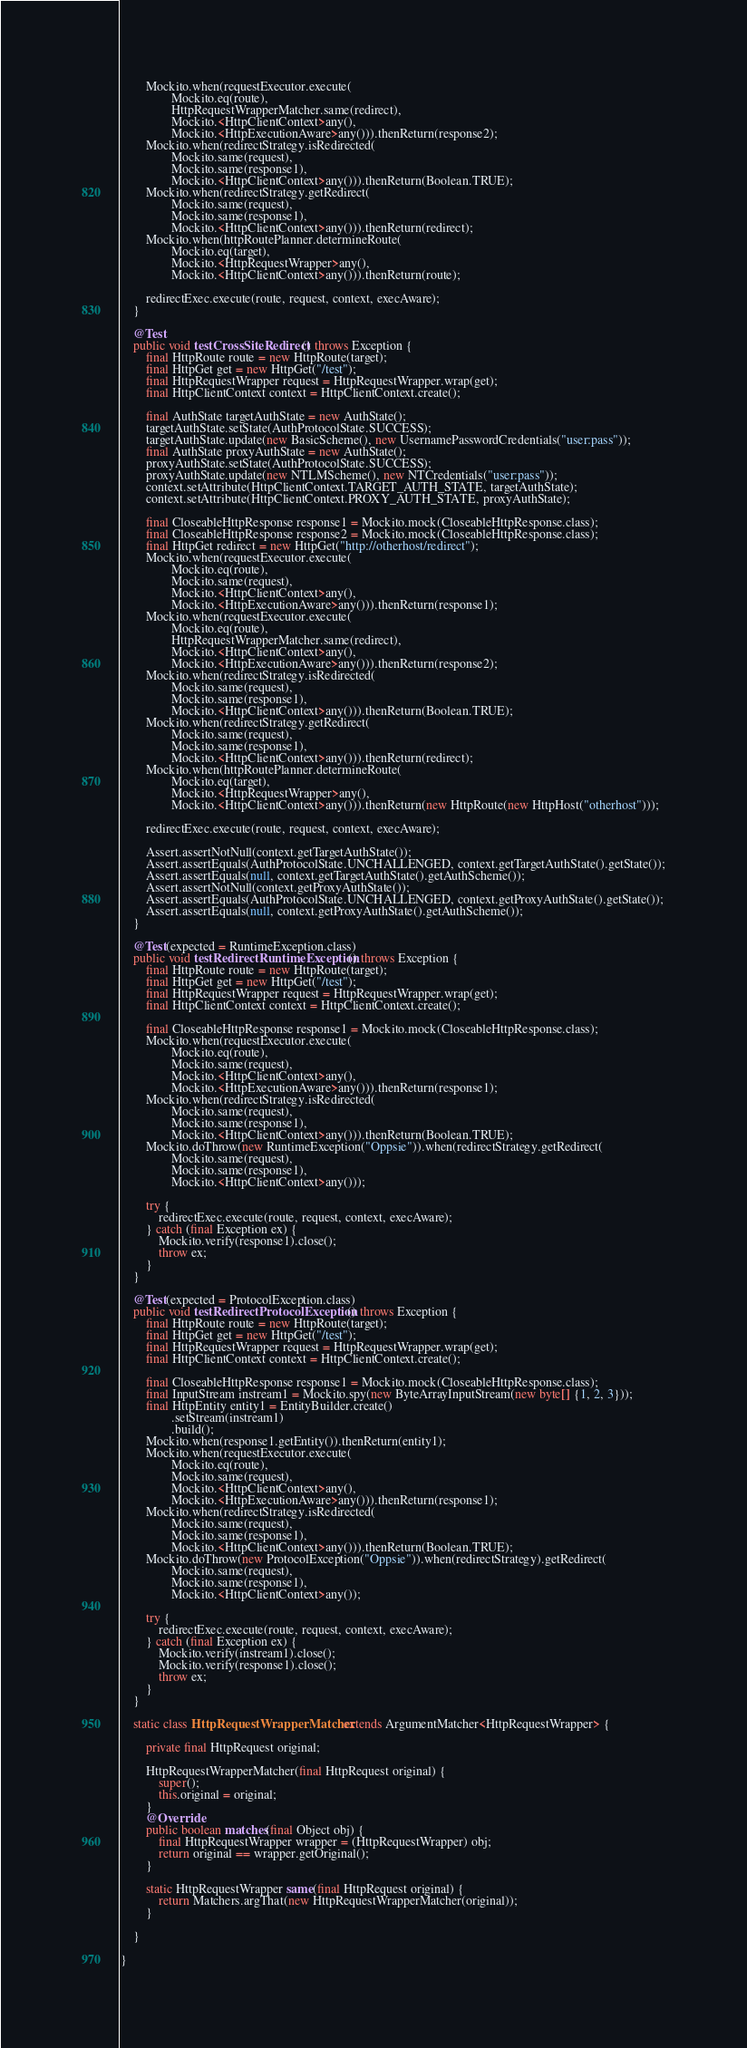<code> <loc_0><loc_0><loc_500><loc_500><_Java_>        Mockito.when(requestExecutor.execute(
                Mockito.eq(route),
                HttpRequestWrapperMatcher.same(redirect),
                Mockito.<HttpClientContext>any(),
                Mockito.<HttpExecutionAware>any())).thenReturn(response2);
        Mockito.when(redirectStrategy.isRedirected(
                Mockito.same(request),
                Mockito.same(response1),
                Mockito.<HttpClientContext>any())).thenReturn(Boolean.TRUE);
        Mockito.when(redirectStrategy.getRedirect(
                Mockito.same(request),
                Mockito.same(response1),
                Mockito.<HttpClientContext>any())).thenReturn(redirect);
        Mockito.when(httpRoutePlanner.determineRoute(
                Mockito.eq(target),
                Mockito.<HttpRequestWrapper>any(),
                Mockito.<HttpClientContext>any())).thenReturn(route);

        redirectExec.execute(route, request, context, execAware);
    }

    @Test
    public void testCrossSiteRedirect() throws Exception {
        final HttpRoute route = new HttpRoute(target);
        final HttpGet get = new HttpGet("/test");
        final HttpRequestWrapper request = HttpRequestWrapper.wrap(get);
        final HttpClientContext context = HttpClientContext.create();

        final AuthState targetAuthState = new AuthState();
        targetAuthState.setState(AuthProtocolState.SUCCESS);
        targetAuthState.update(new BasicScheme(), new UsernamePasswordCredentials("user:pass"));
        final AuthState proxyAuthState = new AuthState();
        proxyAuthState.setState(AuthProtocolState.SUCCESS);
        proxyAuthState.update(new NTLMScheme(), new NTCredentials("user:pass"));
        context.setAttribute(HttpClientContext.TARGET_AUTH_STATE, targetAuthState);
        context.setAttribute(HttpClientContext.PROXY_AUTH_STATE, proxyAuthState);

        final CloseableHttpResponse response1 = Mockito.mock(CloseableHttpResponse.class);
        final CloseableHttpResponse response2 = Mockito.mock(CloseableHttpResponse.class);
        final HttpGet redirect = new HttpGet("http://otherhost/redirect");
        Mockito.when(requestExecutor.execute(
                Mockito.eq(route),
                Mockito.same(request),
                Mockito.<HttpClientContext>any(),
                Mockito.<HttpExecutionAware>any())).thenReturn(response1);
        Mockito.when(requestExecutor.execute(
                Mockito.eq(route),
                HttpRequestWrapperMatcher.same(redirect),
                Mockito.<HttpClientContext>any(),
                Mockito.<HttpExecutionAware>any())).thenReturn(response2);
        Mockito.when(redirectStrategy.isRedirected(
                Mockito.same(request),
                Mockito.same(response1),
                Mockito.<HttpClientContext>any())).thenReturn(Boolean.TRUE);
        Mockito.when(redirectStrategy.getRedirect(
                Mockito.same(request),
                Mockito.same(response1),
                Mockito.<HttpClientContext>any())).thenReturn(redirect);
        Mockito.when(httpRoutePlanner.determineRoute(
                Mockito.eq(target),
                Mockito.<HttpRequestWrapper>any(),
                Mockito.<HttpClientContext>any())).thenReturn(new HttpRoute(new HttpHost("otherhost")));

        redirectExec.execute(route, request, context, execAware);

        Assert.assertNotNull(context.getTargetAuthState());
        Assert.assertEquals(AuthProtocolState.UNCHALLENGED, context.getTargetAuthState().getState());
        Assert.assertEquals(null, context.getTargetAuthState().getAuthScheme());
        Assert.assertNotNull(context.getProxyAuthState());
        Assert.assertEquals(AuthProtocolState.UNCHALLENGED, context.getProxyAuthState().getState());
        Assert.assertEquals(null, context.getProxyAuthState().getAuthScheme());
    }

    @Test(expected = RuntimeException.class)
    public void testRedirectRuntimeException() throws Exception {
        final HttpRoute route = new HttpRoute(target);
        final HttpGet get = new HttpGet("/test");
        final HttpRequestWrapper request = HttpRequestWrapper.wrap(get);
        final HttpClientContext context = HttpClientContext.create();

        final CloseableHttpResponse response1 = Mockito.mock(CloseableHttpResponse.class);
        Mockito.when(requestExecutor.execute(
                Mockito.eq(route),
                Mockito.same(request),
                Mockito.<HttpClientContext>any(),
                Mockito.<HttpExecutionAware>any())).thenReturn(response1);
        Mockito.when(redirectStrategy.isRedirected(
                Mockito.same(request),
                Mockito.same(response1),
                Mockito.<HttpClientContext>any())).thenReturn(Boolean.TRUE);
        Mockito.doThrow(new RuntimeException("Oppsie")).when(redirectStrategy.getRedirect(
                Mockito.same(request),
                Mockito.same(response1),
                Mockito.<HttpClientContext>any()));

        try {
            redirectExec.execute(route, request, context, execAware);
        } catch (final Exception ex) {
            Mockito.verify(response1).close();
            throw ex;
        }
    }

    @Test(expected = ProtocolException.class)
    public void testRedirectProtocolException() throws Exception {
        final HttpRoute route = new HttpRoute(target);
        final HttpGet get = new HttpGet("/test");
        final HttpRequestWrapper request = HttpRequestWrapper.wrap(get);
        final HttpClientContext context = HttpClientContext.create();

        final CloseableHttpResponse response1 = Mockito.mock(CloseableHttpResponse.class);
        final InputStream instream1 = Mockito.spy(new ByteArrayInputStream(new byte[] {1, 2, 3}));
        final HttpEntity entity1 = EntityBuilder.create()
                .setStream(instream1)
                .build();
        Mockito.when(response1.getEntity()).thenReturn(entity1);
        Mockito.when(requestExecutor.execute(
                Mockito.eq(route),
                Mockito.same(request),
                Mockito.<HttpClientContext>any(),
                Mockito.<HttpExecutionAware>any())).thenReturn(response1);
        Mockito.when(redirectStrategy.isRedirected(
                Mockito.same(request),
                Mockito.same(response1),
                Mockito.<HttpClientContext>any())).thenReturn(Boolean.TRUE);
        Mockito.doThrow(new ProtocolException("Oppsie")).when(redirectStrategy).getRedirect(
                Mockito.same(request),
                Mockito.same(response1),
                Mockito.<HttpClientContext>any());

        try {
            redirectExec.execute(route, request, context, execAware);
        } catch (final Exception ex) {
            Mockito.verify(instream1).close();
            Mockito.verify(response1).close();
            throw ex;
        }
    }

    static class HttpRequestWrapperMatcher extends ArgumentMatcher<HttpRequestWrapper> {

        private final HttpRequest original;

        HttpRequestWrapperMatcher(final HttpRequest original) {
            super();
            this.original = original;
        }
        @Override
        public boolean matches(final Object obj) {
            final HttpRequestWrapper wrapper = (HttpRequestWrapper) obj;
            return original == wrapper.getOriginal();
        }

        static HttpRequestWrapper same(final HttpRequest original) {
            return Matchers.argThat(new HttpRequestWrapperMatcher(original));
        }

    }

}
</code> 